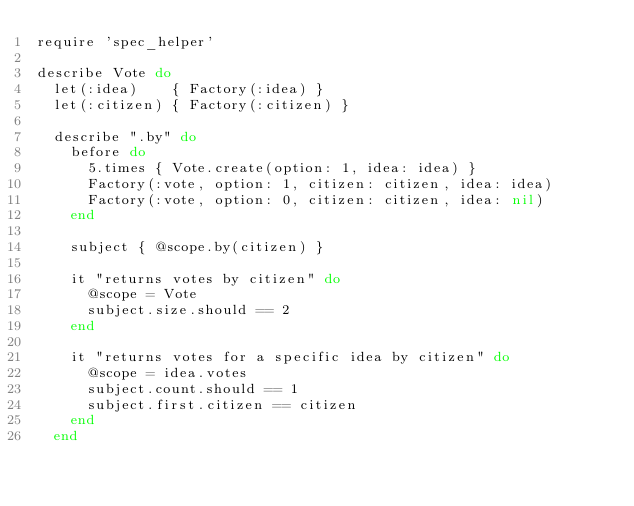Convert code to text. <code><loc_0><loc_0><loc_500><loc_500><_Ruby_>require 'spec_helper'

describe Vote do
  let(:idea)    { Factory(:idea) }
  let(:citizen) { Factory(:citizen) }
  
  describe ".by" do
    before do
      5.times { Vote.create(option: 1, idea: idea) }
      Factory(:vote, option: 1, citizen: citizen, idea: idea)
      Factory(:vote, option: 0, citizen: citizen, idea: nil)
    end

    subject { @scope.by(citizen) }
    
    it "returns votes by citizen" do
      @scope = Vote
      subject.size.should == 2
    end

    it "returns votes for a specific idea by citizen" do
      @scope = idea.votes
      subject.count.should == 1
      subject.first.citizen == citizen
    end
  end
  </code> 